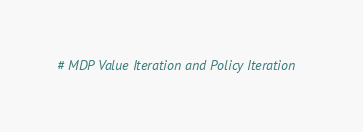<code> <loc_0><loc_0><loc_500><loc_500><_Python_># MDP Value Iteration and Policy Iteration</code> 